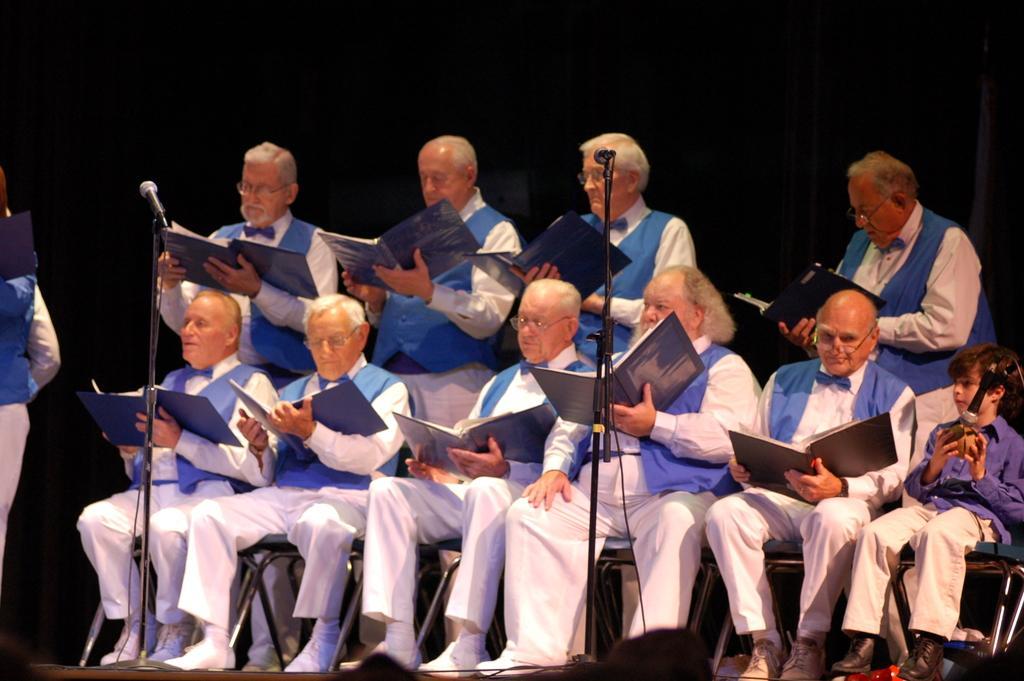Could you give a brief overview of what you see in this image? In this image I can see few men sitting on the chairs by holding books in their hands. At the back of these men some more men are standing. They are also holding books in their hands and looking into the books. In front of these people there are two mike stands. On the right side there is a boy sitting on a chair and holding an object in the hands. The background is in black color. 